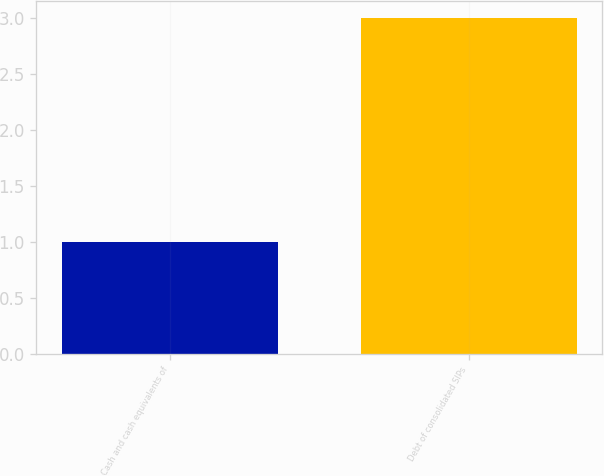Convert chart to OTSL. <chart><loc_0><loc_0><loc_500><loc_500><bar_chart><fcel>Cash and cash equivalents of<fcel>Debt of consolidated SIPs<nl><fcel>1<fcel>3<nl></chart> 